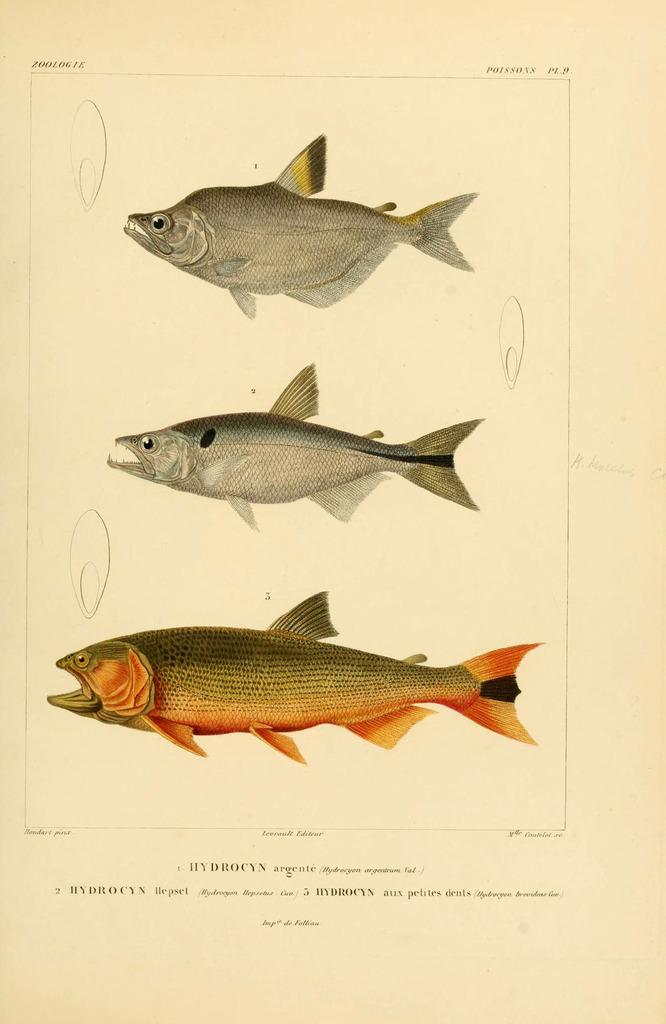What is depicted on the paper in the image? There are fishes on the paper in the image. What else can be seen at the bottom of the image? There is text at the bottom of the image. What type of sound can be heard coming from the fishes in the image? There is no sound coming from the fishes in the image, as they are depicted on a paper and not real. 